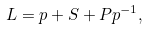<formula> <loc_0><loc_0><loc_500><loc_500>L = p + S + P p ^ { - 1 } ,</formula> 